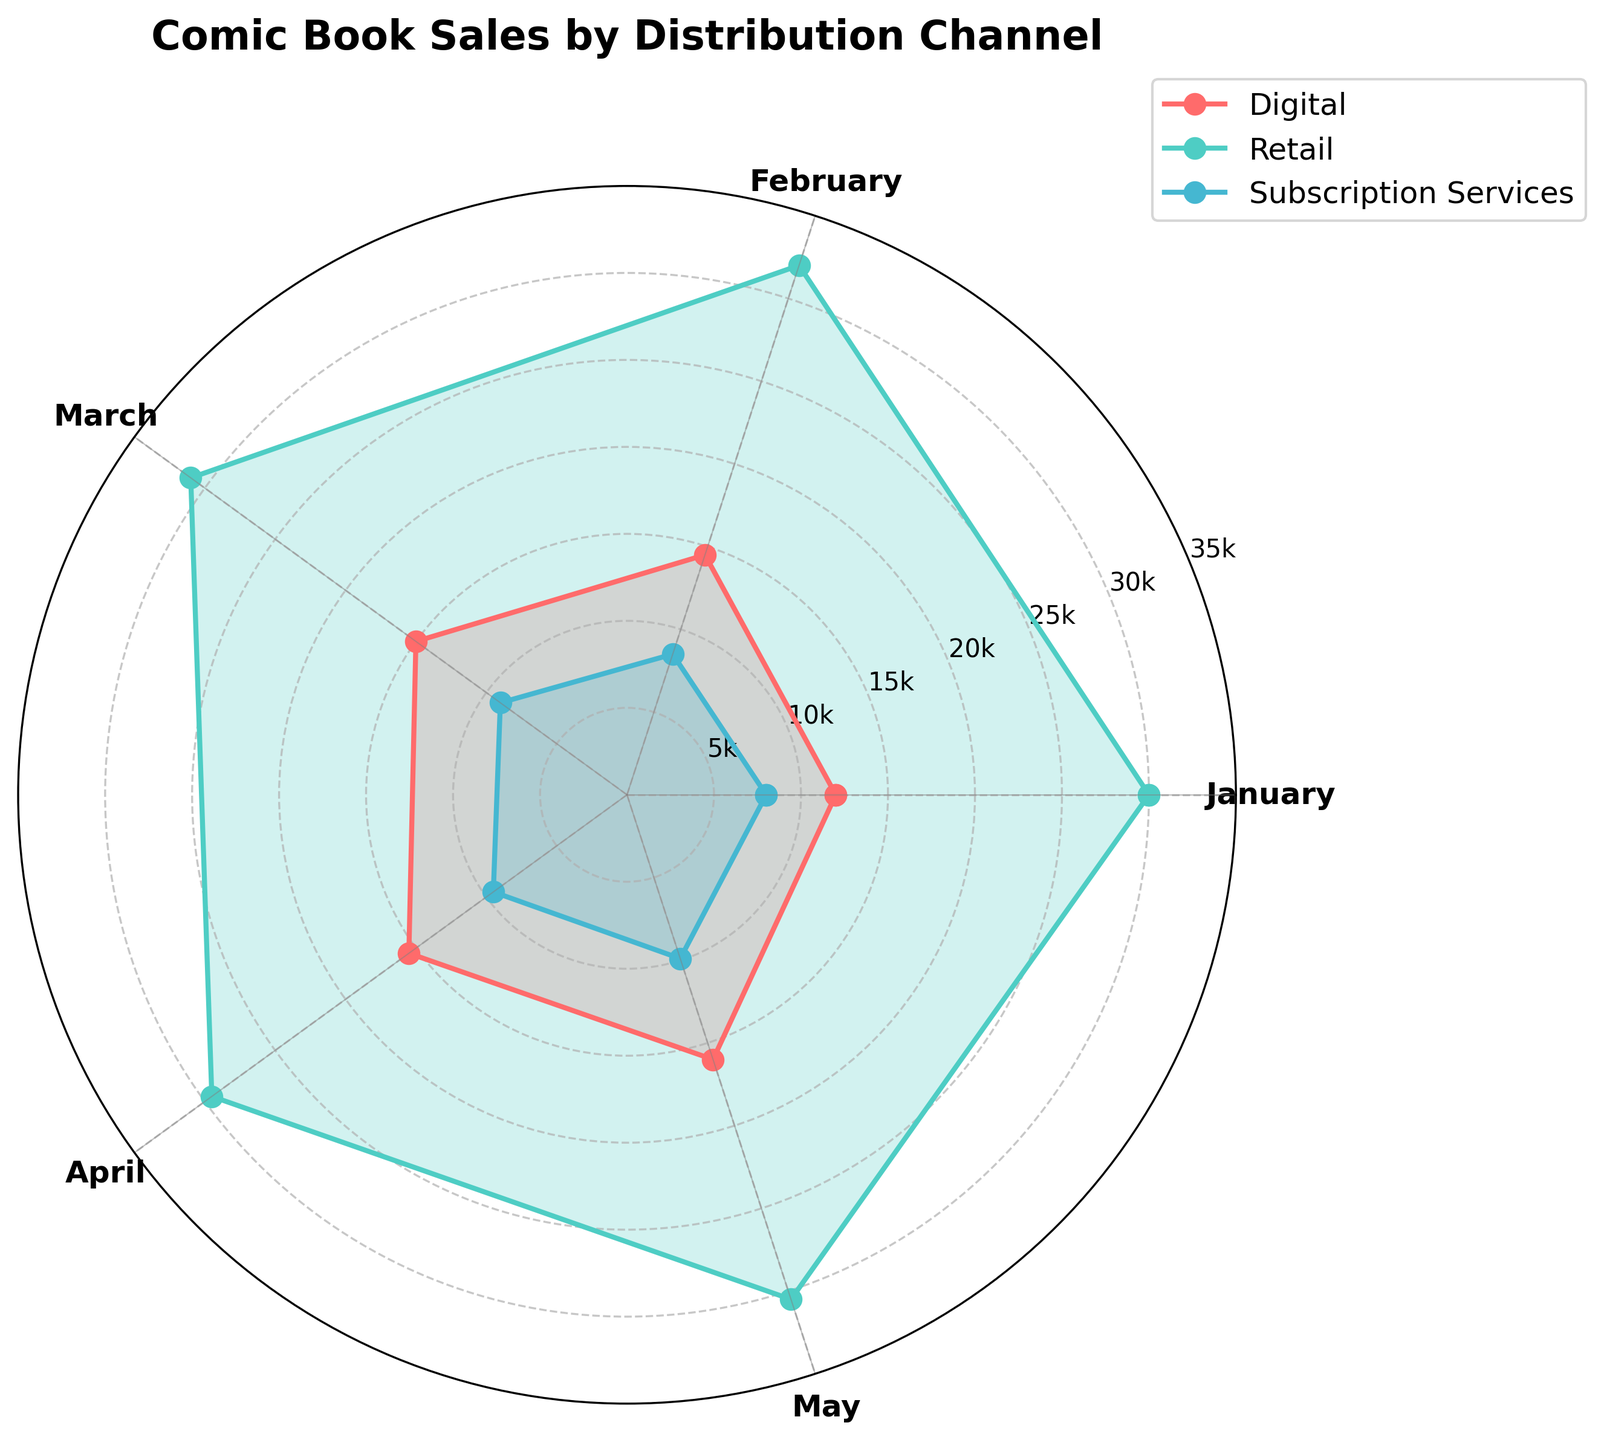What is the title of the radar chart? The title is located at the top of the radar chart and describes what the figure is about.
Answer: Comic Book Sales by Distribution Channel Which distribution channel had the highest sales in January? Observe the sales data points for January for each channel. The highest point corresponds to the channel with the highest sales.
Answer: Retail How do the sales in May for Digital and Subscription Services compare? Locate the data points for May for both Digital and Subscription Services channels. Compare the values to see which is higher or lower.
Answer: Digital is higher What is the general trend for Retail sales from January to May? Observe the points for Retail from January to May and note if they increase, decrease, or fluctuate.
Answer: Fluctuate Which month shows the highest sales for Subscription Services? Look for the peak point of the Subscription Services line on the radar chart and note the corresponding month.
Answer: May What is the average sales value for Digital from January to May? Sum the Digital sales values from January (12000), February (14500), March (15000), April (15500), and May (16000), then divide by the number of months (5).
Answer: 14600 Compare the sales trends of Digital and Retail channels over the five months. Check the shape of the lines for both Digital and Retail channels, noting how they increase or decrease over the period.
Answer: Digital increases steadily, Retail fluctuates For which month are all three channels closest in sales values? Identify the month where the data points for Digital, Retail, and Subscription Services are nearest to each other. Compare the values for one another.
Answer: April What is the difference in sales between Retail and Digital channels in March? Look at the data points for Retail and Digital in March. Subtract the Digital sales value from the Retail sales value (31000 - 15000).
Answer: 16000 